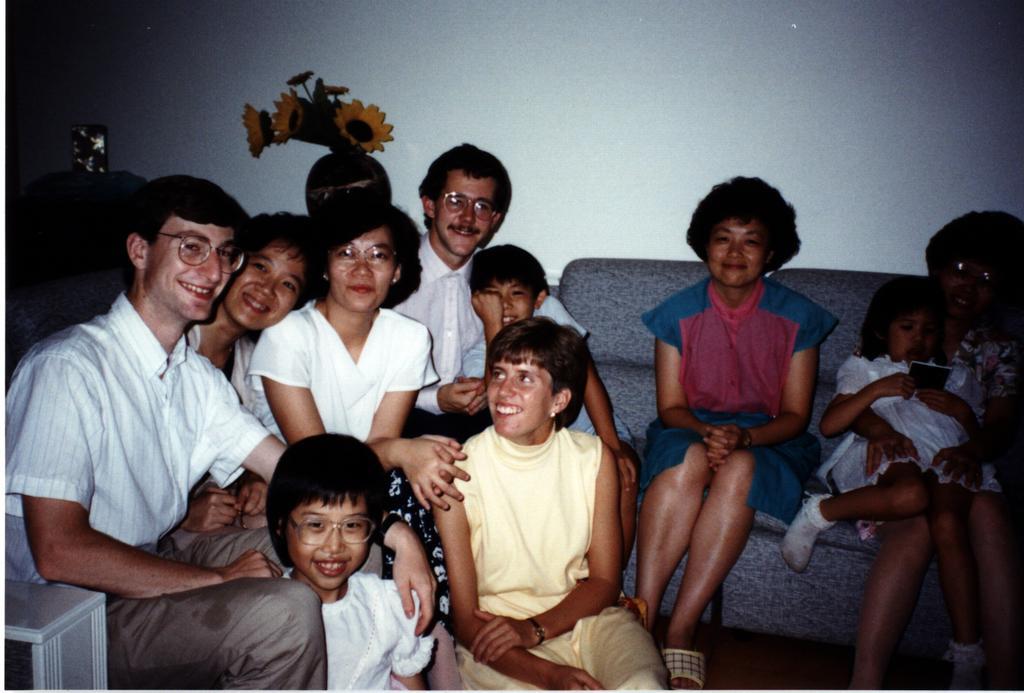Describe this image in one or two sentences. In this picture I can see few people are sitting, behind there is a flowerpot placed in front of the wall. 